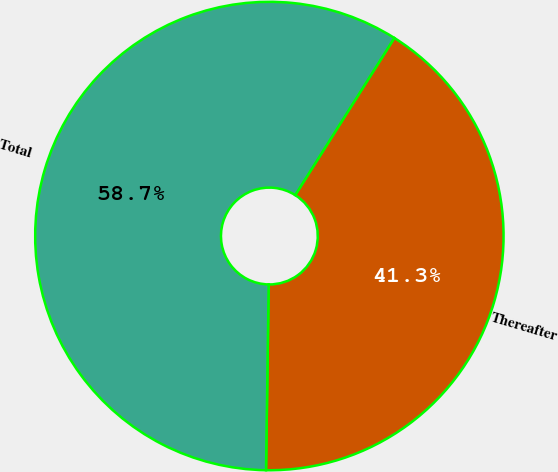Convert chart to OTSL. <chart><loc_0><loc_0><loc_500><loc_500><pie_chart><fcel>Thereafter<fcel>Total<nl><fcel>41.27%<fcel>58.73%<nl></chart> 